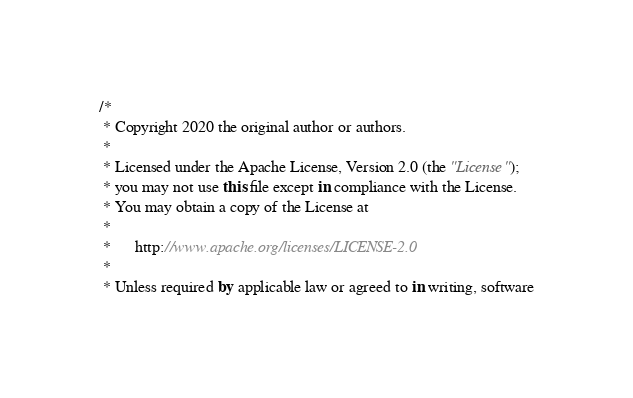Convert code to text. <code><loc_0><loc_0><loc_500><loc_500><_Kotlin_>/*
 * Copyright 2020 the original author or authors.
 *
 * Licensed under the Apache License, Version 2.0 (the "License");
 * you may not use this file except in compliance with the License.
 * You may obtain a copy of the License at
 *
 *      http://www.apache.org/licenses/LICENSE-2.0
 *
 * Unless required by applicable law or agreed to in writing, software</code> 